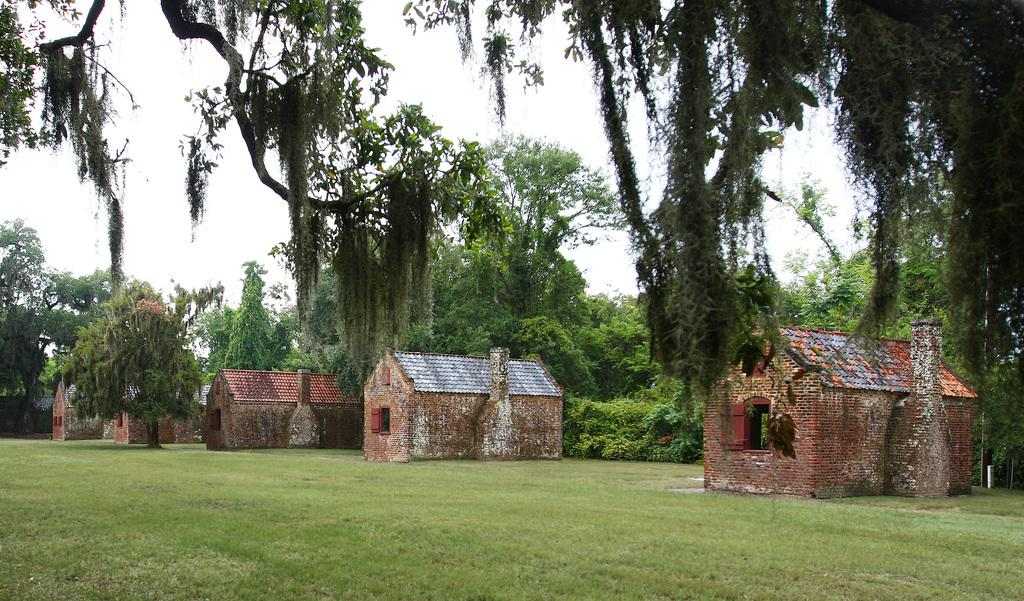What structures are located in the center of the image? There are sheds in the center of the image. What type of vegetation is visible at the bottom of the image? Grass is visible at the bottom of the image. What can be seen in the background of the image? There are trees and the sky visible in the background of the image. What type of card is being used to measure the pollution in the image? There is no card or mention of pollution in the image; it features sheds, grass, trees, and the sky. 